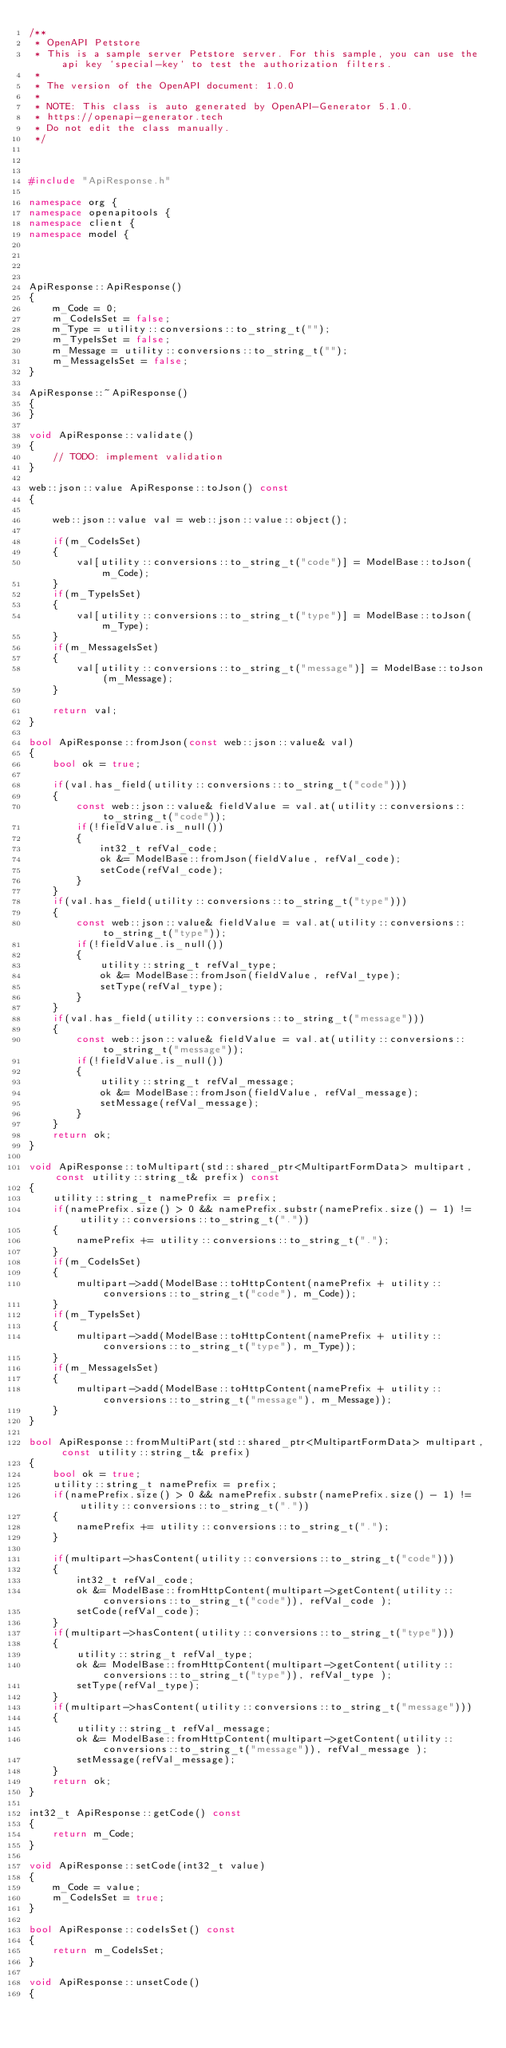Convert code to text. <code><loc_0><loc_0><loc_500><loc_500><_C++_>/**
 * OpenAPI Petstore
 * This is a sample server Petstore server. For this sample, you can use the api key `special-key` to test the authorization filters.
 *
 * The version of the OpenAPI document: 1.0.0
 *
 * NOTE: This class is auto generated by OpenAPI-Generator 5.1.0.
 * https://openapi-generator.tech
 * Do not edit the class manually.
 */



#include "ApiResponse.h"

namespace org {
namespace openapitools {
namespace client {
namespace model {




ApiResponse::ApiResponse()
{
    m_Code = 0;
    m_CodeIsSet = false;
    m_Type = utility::conversions::to_string_t("");
    m_TypeIsSet = false;
    m_Message = utility::conversions::to_string_t("");
    m_MessageIsSet = false;
}

ApiResponse::~ApiResponse()
{
}

void ApiResponse::validate()
{
    // TODO: implement validation
}

web::json::value ApiResponse::toJson() const
{

    web::json::value val = web::json::value::object();
    
    if(m_CodeIsSet)
    {
        val[utility::conversions::to_string_t("code")] = ModelBase::toJson(m_Code);
    }
    if(m_TypeIsSet)
    {
        val[utility::conversions::to_string_t("type")] = ModelBase::toJson(m_Type);
    }
    if(m_MessageIsSet)
    {
        val[utility::conversions::to_string_t("message")] = ModelBase::toJson(m_Message);
    }

    return val;
}

bool ApiResponse::fromJson(const web::json::value& val)
{
    bool ok = true;
    
    if(val.has_field(utility::conversions::to_string_t("code")))
    {
        const web::json::value& fieldValue = val.at(utility::conversions::to_string_t("code"));
        if(!fieldValue.is_null())
        {
            int32_t refVal_code;
            ok &= ModelBase::fromJson(fieldValue, refVal_code);
            setCode(refVal_code);
        }
    }
    if(val.has_field(utility::conversions::to_string_t("type")))
    {
        const web::json::value& fieldValue = val.at(utility::conversions::to_string_t("type"));
        if(!fieldValue.is_null())
        {
            utility::string_t refVal_type;
            ok &= ModelBase::fromJson(fieldValue, refVal_type);
            setType(refVal_type);
        }
    }
    if(val.has_field(utility::conversions::to_string_t("message")))
    {
        const web::json::value& fieldValue = val.at(utility::conversions::to_string_t("message"));
        if(!fieldValue.is_null())
        {
            utility::string_t refVal_message;
            ok &= ModelBase::fromJson(fieldValue, refVal_message);
            setMessage(refVal_message);
        }
    }
    return ok;
}

void ApiResponse::toMultipart(std::shared_ptr<MultipartFormData> multipart, const utility::string_t& prefix) const
{
    utility::string_t namePrefix = prefix;
    if(namePrefix.size() > 0 && namePrefix.substr(namePrefix.size() - 1) != utility::conversions::to_string_t("."))
    {
        namePrefix += utility::conversions::to_string_t(".");
    }
    if(m_CodeIsSet)
    {
        multipart->add(ModelBase::toHttpContent(namePrefix + utility::conversions::to_string_t("code"), m_Code));
    }
    if(m_TypeIsSet)
    {
        multipart->add(ModelBase::toHttpContent(namePrefix + utility::conversions::to_string_t("type"), m_Type));
    }
    if(m_MessageIsSet)
    {
        multipart->add(ModelBase::toHttpContent(namePrefix + utility::conversions::to_string_t("message"), m_Message));
    }
}

bool ApiResponse::fromMultiPart(std::shared_ptr<MultipartFormData> multipart, const utility::string_t& prefix)
{
    bool ok = true;
    utility::string_t namePrefix = prefix;
    if(namePrefix.size() > 0 && namePrefix.substr(namePrefix.size() - 1) != utility::conversions::to_string_t("."))
    {
        namePrefix += utility::conversions::to_string_t(".");
    }

    if(multipart->hasContent(utility::conversions::to_string_t("code")))
    {
        int32_t refVal_code;
        ok &= ModelBase::fromHttpContent(multipart->getContent(utility::conversions::to_string_t("code")), refVal_code );
        setCode(refVal_code);
    }
    if(multipart->hasContent(utility::conversions::to_string_t("type")))
    {
        utility::string_t refVal_type;
        ok &= ModelBase::fromHttpContent(multipart->getContent(utility::conversions::to_string_t("type")), refVal_type );
        setType(refVal_type);
    }
    if(multipart->hasContent(utility::conversions::to_string_t("message")))
    {
        utility::string_t refVal_message;
        ok &= ModelBase::fromHttpContent(multipart->getContent(utility::conversions::to_string_t("message")), refVal_message );
        setMessage(refVal_message);
    }
    return ok;
}

int32_t ApiResponse::getCode() const
{
    return m_Code;
}

void ApiResponse::setCode(int32_t value)
{
    m_Code = value;
    m_CodeIsSet = true;
}

bool ApiResponse::codeIsSet() const
{
    return m_CodeIsSet;
}

void ApiResponse::unsetCode()
{</code> 